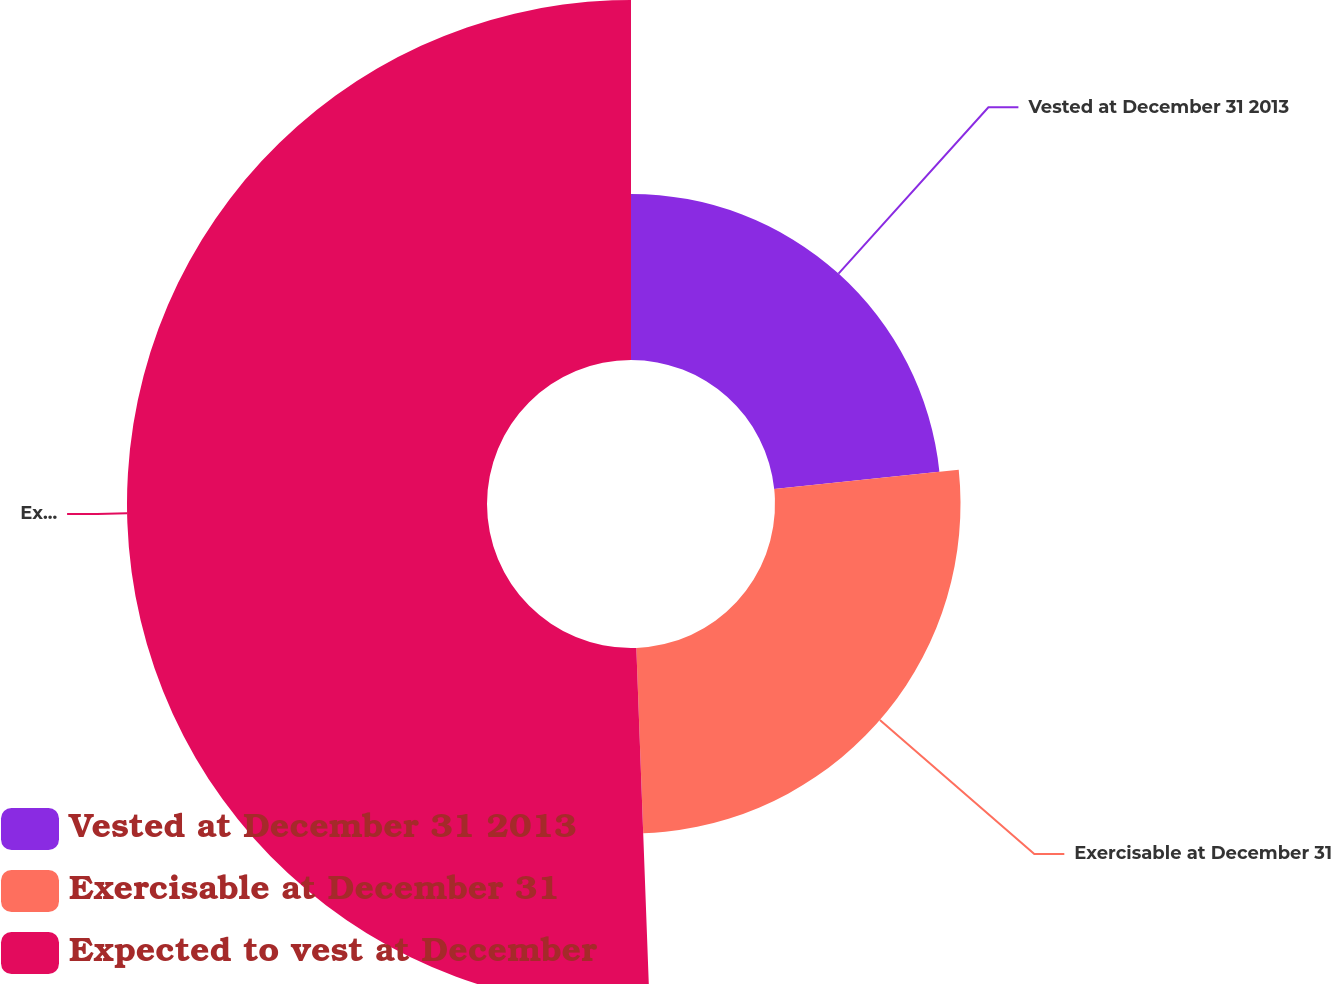Convert chart. <chart><loc_0><loc_0><loc_500><loc_500><pie_chart><fcel>Vested at December 31 2013<fcel>Exercisable at December 31<fcel>Expected to vest at December<nl><fcel>23.34%<fcel>26.07%<fcel>50.59%<nl></chart> 